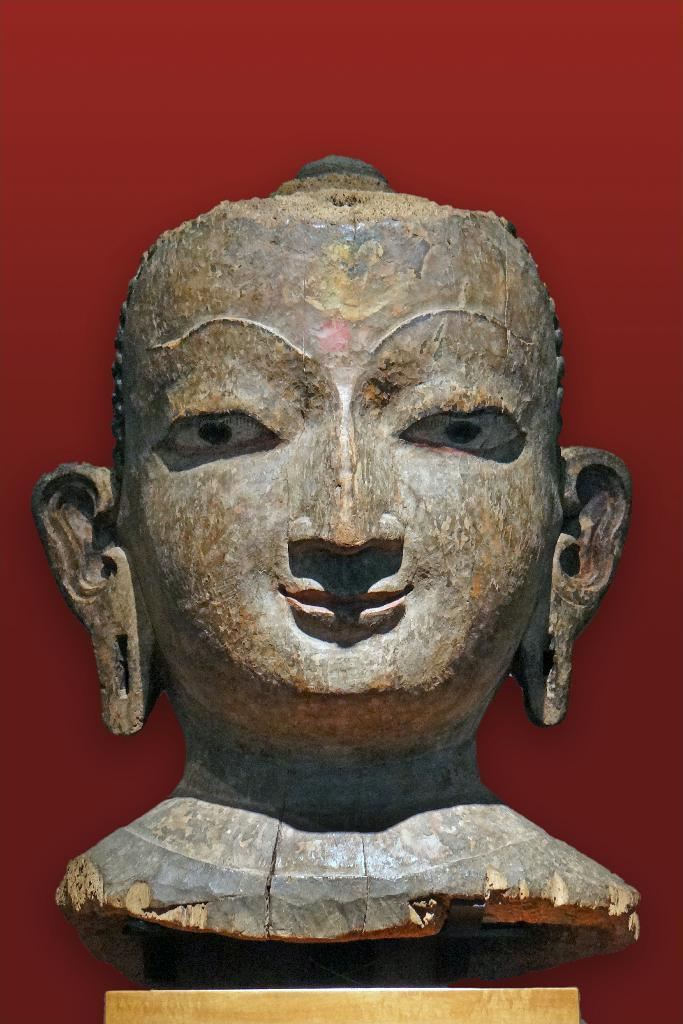What is the main subject of the image? There is a statue of a person's face in the image. What can be seen in the background of the image? The background of the image is red. What is the weight of the nation depicted in the image? There is no nation depicted in the image, only a statue of a person's face. How does the statue walk in the image? The statue is not walking in the image; it is a stationary object. 